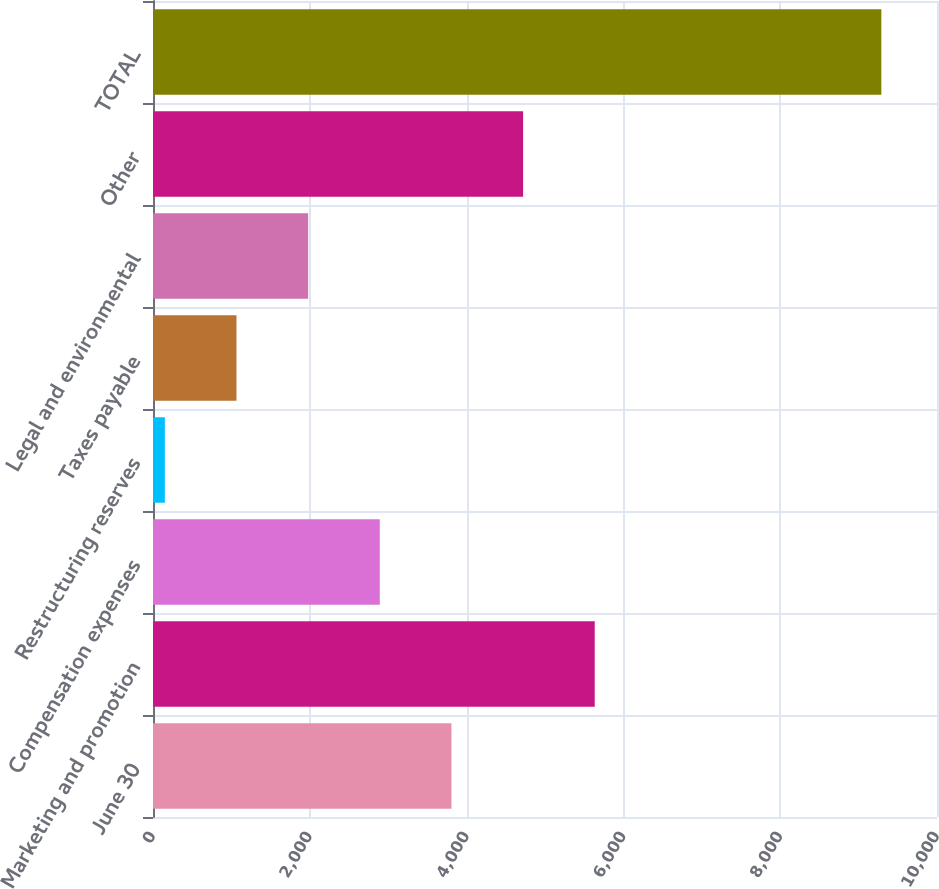Convert chart. <chart><loc_0><loc_0><loc_500><loc_500><bar_chart><fcel>June 30<fcel>Marketing and promotion<fcel>Compensation expenses<fcel>Restructuring reserves<fcel>Taxes payable<fcel>Legal and environmental<fcel>Other<fcel>TOTAL<nl><fcel>3806.6<fcel>5634.4<fcel>2892.7<fcel>151<fcel>1064.9<fcel>1978.8<fcel>4720.5<fcel>9290<nl></chart> 